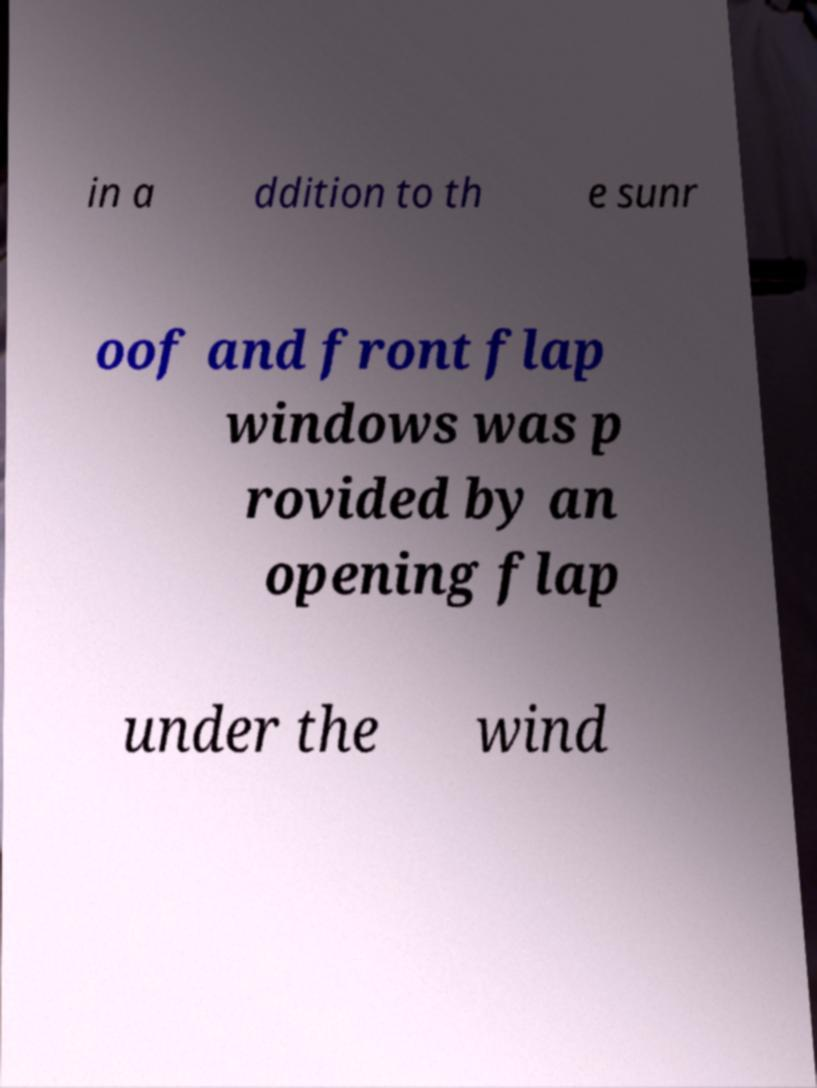Could you assist in decoding the text presented in this image and type it out clearly? in a ddition to th e sunr oof and front flap windows was p rovided by an opening flap under the wind 